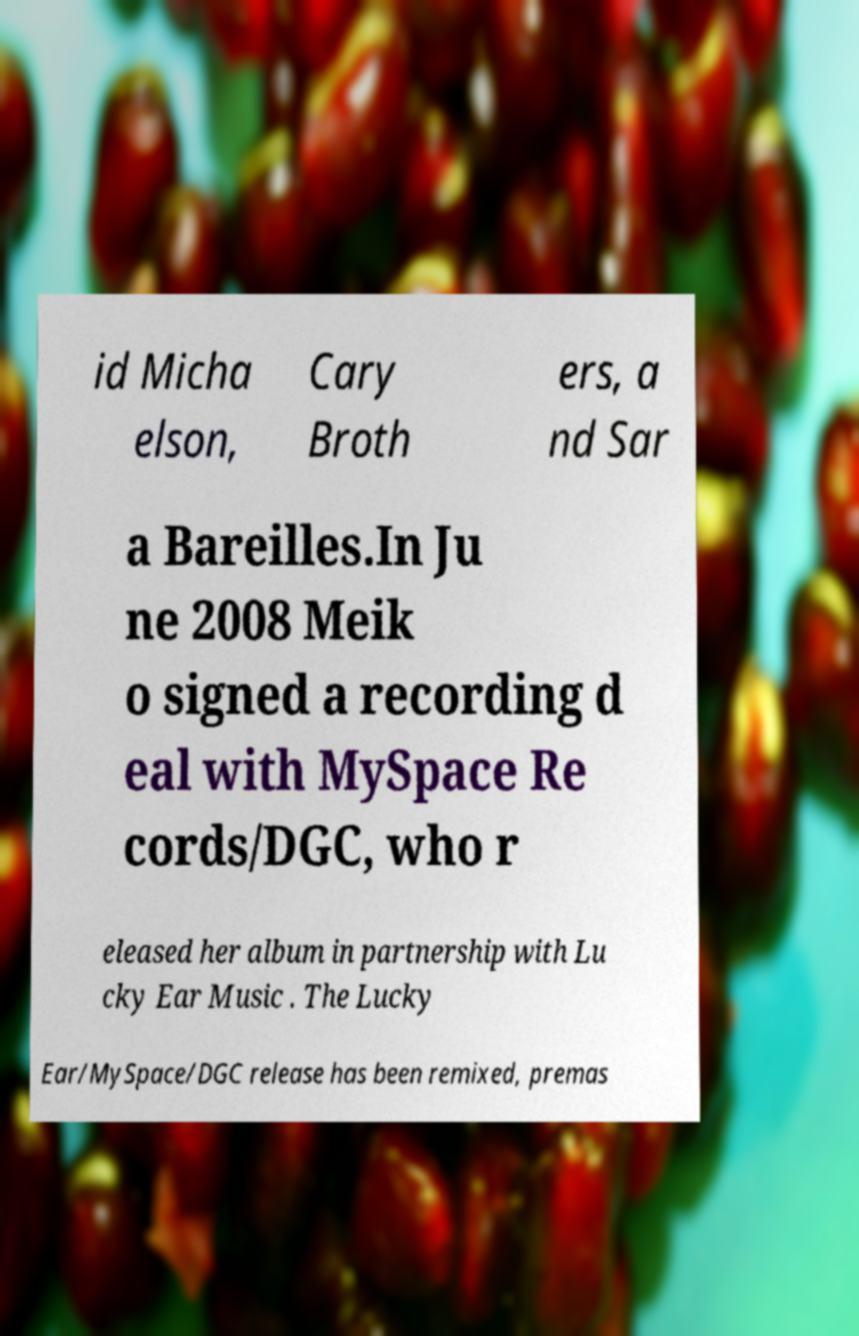Could you extract and type out the text from this image? id Micha elson, Cary Broth ers, a nd Sar a Bareilles.In Ju ne 2008 Meik o signed a recording d eal with MySpace Re cords/DGC, who r eleased her album in partnership with Lu cky Ear Music . The Lucky Ear/MySpace/DGC release has been remixed, premas 